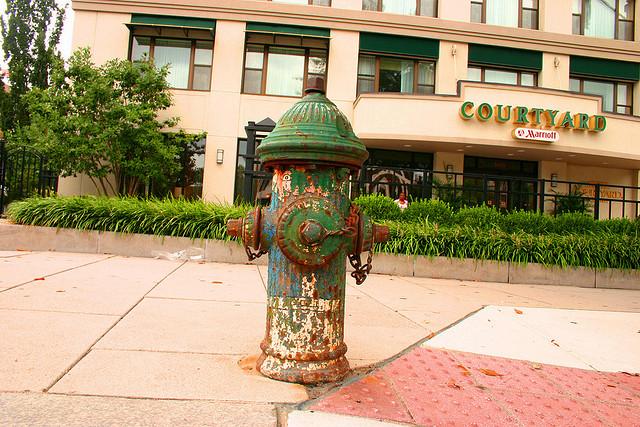What type of building is in the background?
Short answer required. Hotel. What is the picture capturing?
Short answer required. Fire hydrant. What is the name of the hotel in the background?
Quick response, please. Courtyard. 